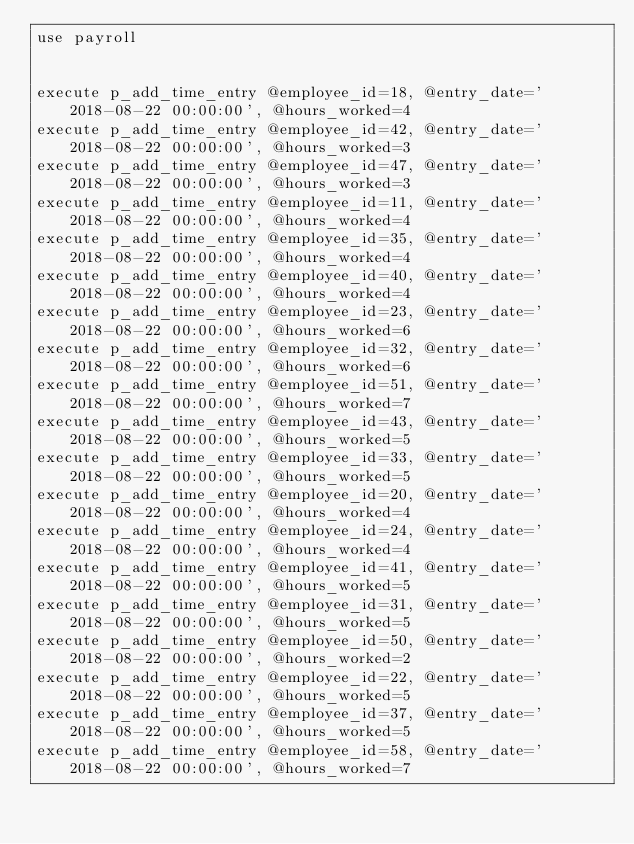Convert code to text. <code><loc_0><loc_0><loc_500><loc_500><_SQL_>use payroll


execute p_add_time_entry @employee_id=18, @entry_date='2018-08-22 00:00:00', @hours_worked=4
execute p_add_time_entry @employee_id=42, @entry_date='2018-08-22 00:00:00', @hours_worked=3
execute p_add_time_entry @employee_id=47, @entry_date='2018-08-22 00:00:00', @hours_worked=3
execute p_add_time_entry @employee_id=11, @entry_date='2018-08-22 00:00:00', @hours_worked=4
execute p_add_time_entry @employee_id=35, @entry_date='2018-08-22 00:00:00', @hours_worked=4
execute p_add_time_entry @employee_id=40, @entry_date='2018-08-22 00:00:00', @hours_worked=4
execute p_add_time_entry @employee_id=23, @entry_date='2018-08-22 00:00:00', @hours_worked=6
execute p_add_time_entry @employee_id=32, @entry_date='2018-08-22 00:00:00', @hours_worked=6
execute p_add_time_entry @employee_id=51, @entry_date='2018-08-22 00:00:00', @hours_worked=7
execute p_add_time_entry @employee_id=43, @entry_date='2018-08-22 00:00:00', @hours_worked=5
execute p_add_time_entry @employee_id=33, @entry_date='2018-08-22 00:00:00', @hours_worked=5
execute p_add_time_entry @employee_id=20, @entry_date='2018-08-22 00:00:00', @hours_worked=4
execute p_add_time_entry @employee_id=24, @entry_date='2018-08-22 00:00:00', @hours_worked=4
execute p_add_time_entry @employee_id=41, @entry_date='2018-08-22 00:00:00', @hours_worked=5
execute p_add_time_entry @employee_id=31, @entry_date='2018-08-22 00:00:00', @hours_worked=5
execute p_add_time_entry @employee_id=50, @entry_date='2018-08-22 00:00:00', @hours_worked=2
execute p_add_time_entry @employee_id=22, @entry_date='2018-08-22 00:00:00', @hours_worked=5
execute p_add_time_entry @employee_id=37, @entry_date='2018-08-22 00:00:00', @hours_worked=5
execute p_add_time_entry @employee_id=58, @entry_date='2018-08-22 00:00:00', @hours_worked=7

</code> 